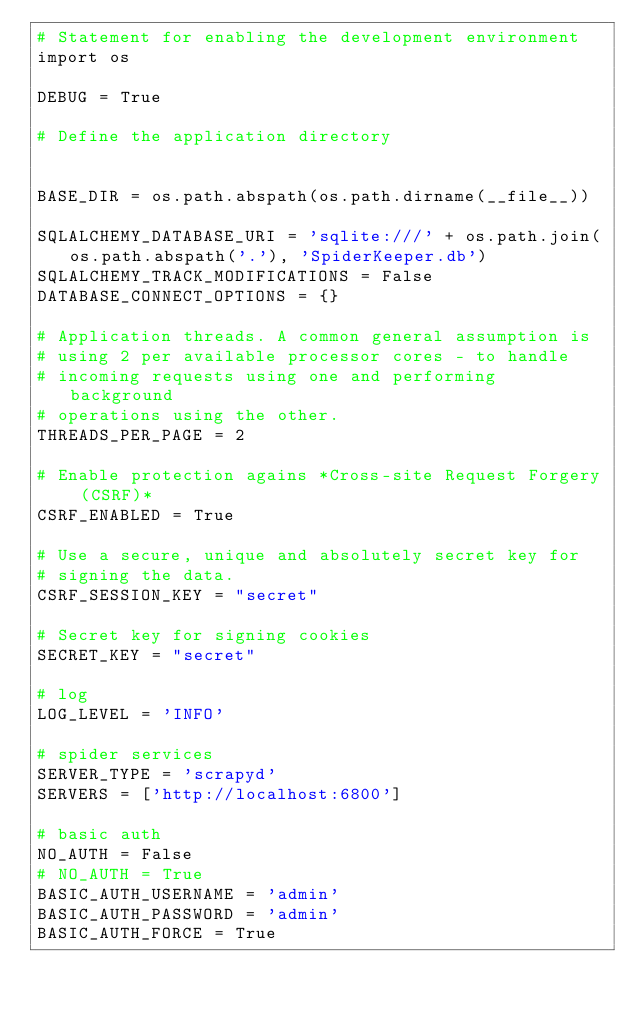Convert code to text. <code><loc_0><loc_0><loc_500><loc_500><_Python_># Statement for enabling the development environment
import os

DEBUG = True

# Define the application directory


BASE_DIR = os.path.abspath(os.path.dirname(__file__))

SQLALCHEMY_DATABASE_URI = 'sqlite:///' + os.path.join(os.path.abspath('.'), 'SpiderKeeper.db')
SQLALCHEMY_TRACK_MODIFICATIONS = False
DATABASE_CONNECT_OPTIONS = {}

# Application threads. A common general assumption is
# using 2 per available processor cores - to handle
# incoming requests using one and performing background
# operations using the other.
THREADS_PER_PAGE = 2

# Enable protection agains *Cross-site Request Forgery (CSRF)*
CSRF_ENABLED = True

# Use a secure, unique and absolutely secret key for
# signing the data.
CSRF_SESSION_KEY = "secret"

# Secret key for signing cookies
SECRET_KEY = "secret"

# log
LOG_LEVEL = 'INFO'

# spider services
SERVER_TYPE = 'scrapyd'
SERVERS = ['http://localhost:6800']

# basic auth
NO_AUTH = False
# NO_AUTH = True
BASIC_AUTH_USERNAME = 'admin'
BASIC_AUTH_PASSWORD = 'admin'
BASIC_AUTH_FORCE = True
</code> 